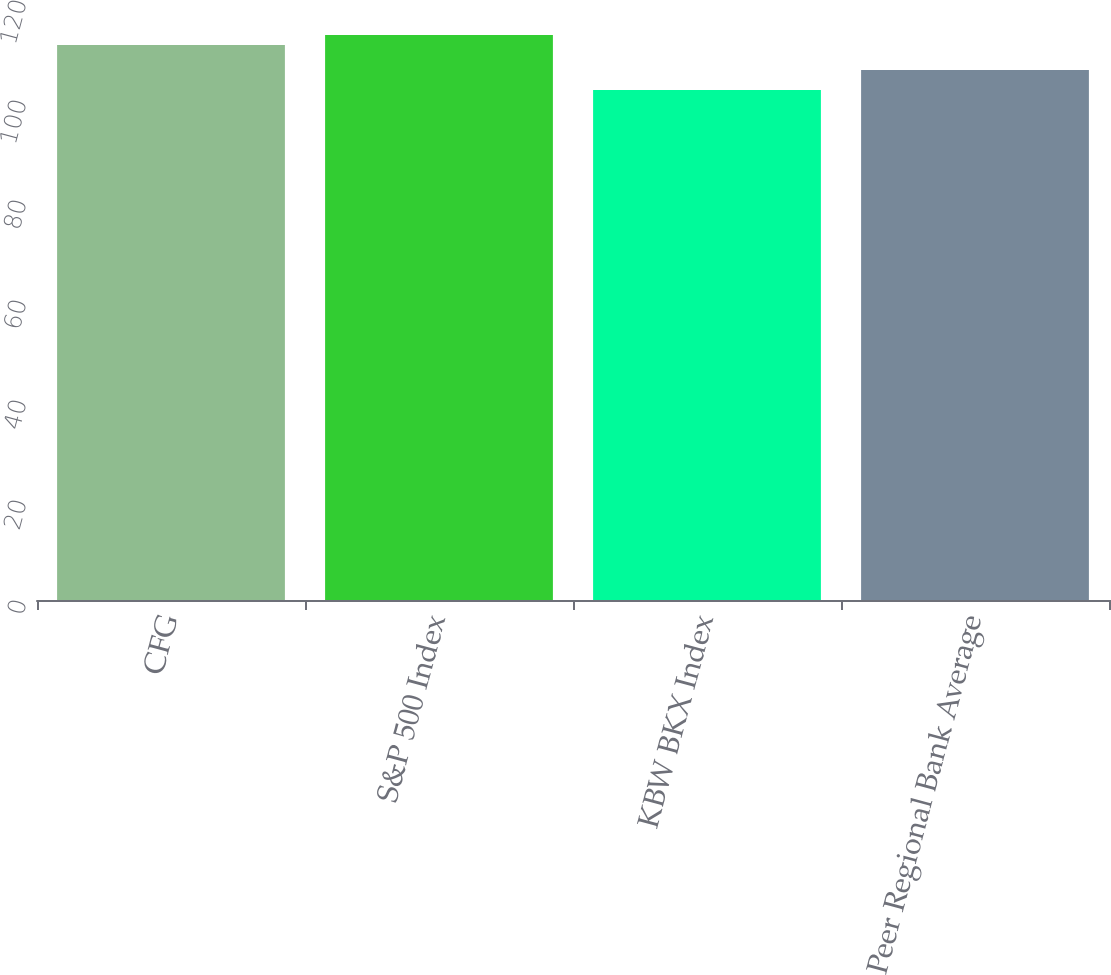<chart> <loc_0><loc_0><loc_500><loc_500><bar_chart><fcel>CFG<fcel>S&P 500 Index<fcel>KBW BKX Index<fcel>Peer Regional Bank Average<nl><fcel>111<fcel>113<fcel>102<fcel>106<nl></chart> 